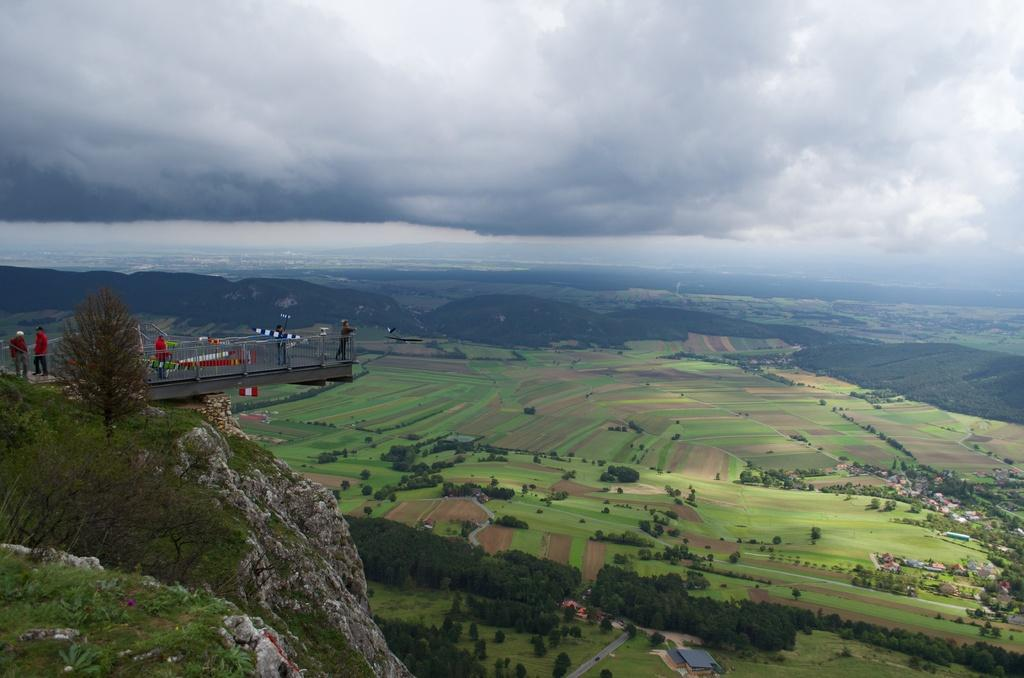What type of landscape feature is present in the image? There is a hill in the image. What type of vegetation can be seen in the image? There are trees in the image. What type of structures are visible in the image? There are houses in the image. What type of ground cover is present in the image? There is grass in the image. What type of surface is visible in the image? There is ground visible in the image. Who or what is present in the image? There are people in the image. What type of architectural feature is on the left side of the image? There is a deck on the left side of the image. What is the weather like in the image? The sky is cloudy in the image. How many fans are visible in the image? There are no fans present in the image. What year is depicted in the image? The image does not depict a specific year; it is a snapshot of a scene. 